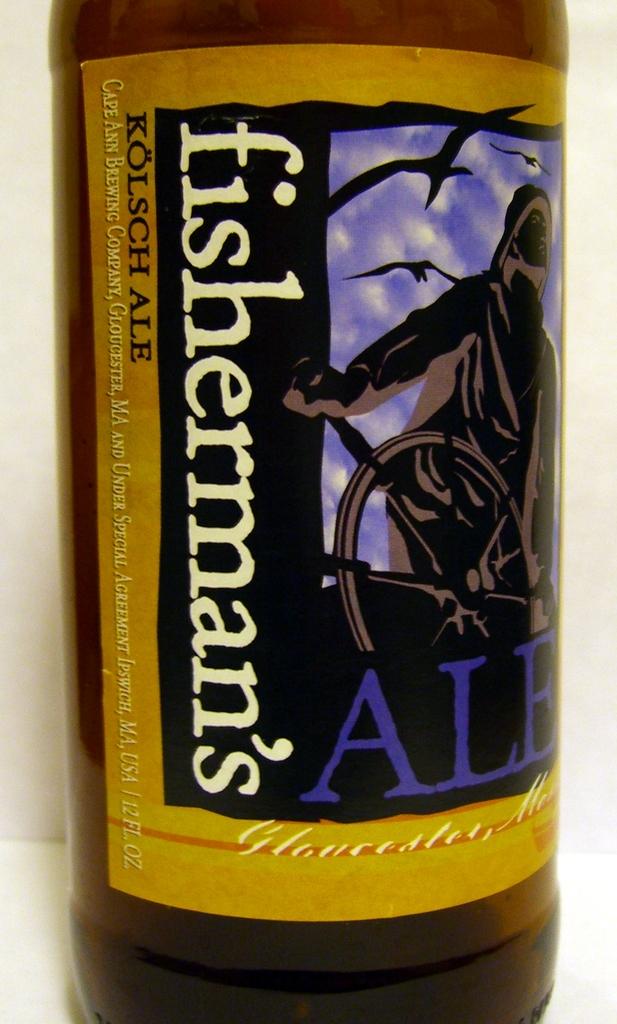How many fluid ounces are in a bottle?
Provide a succinct answer. 12. What is the brand of the beer?
Make the answer very short. Fisherman's. 